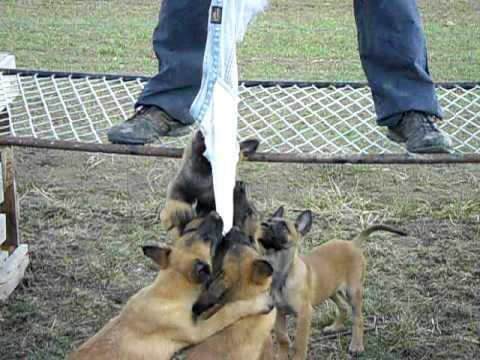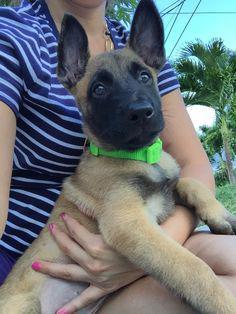The first image is the image on the left, the second image is the image on the right. For the images shown, is this caption "A large-eared dog's tongue is visible as it faces the camera." true? Answer yes or no. No. The first image is the image on the left, the second image is the image on the right. Given the left and right images, does the statement "There is at least one dog sticking its tongue out." hold true? Answer yes or no. No. 